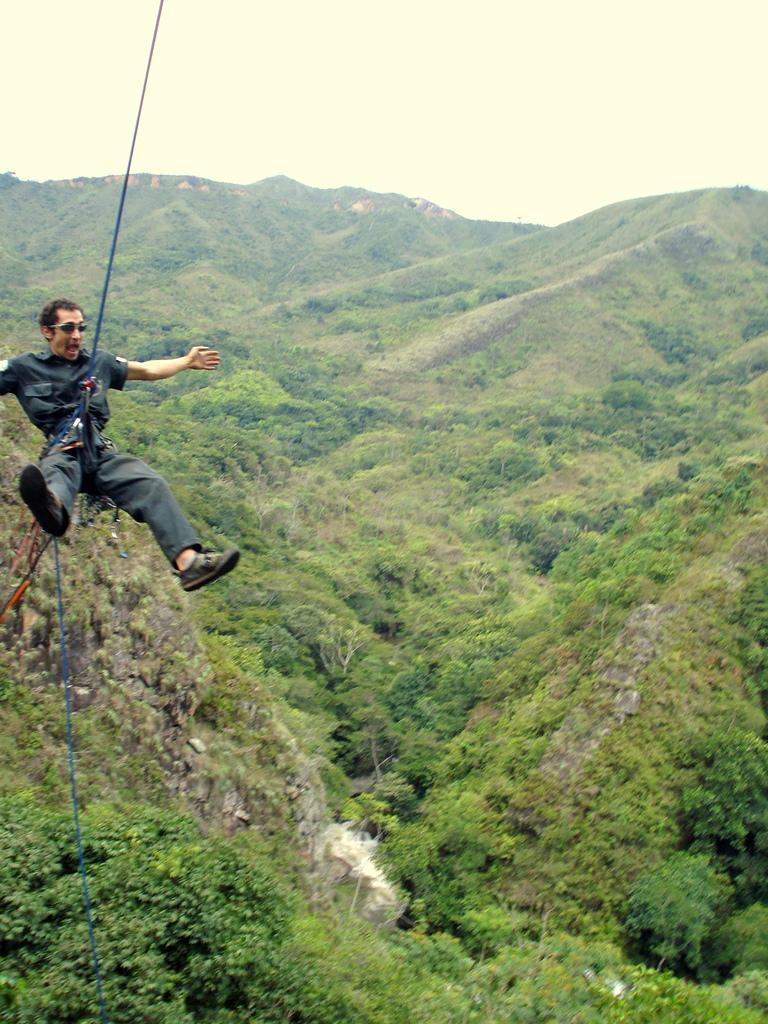How would you summarize this image in a sentence or two? In this picture, we see a man abseiling or paragliding. At the bottom, we see the trees. There are trees and the hills in the background. At the top, we see the sky. 